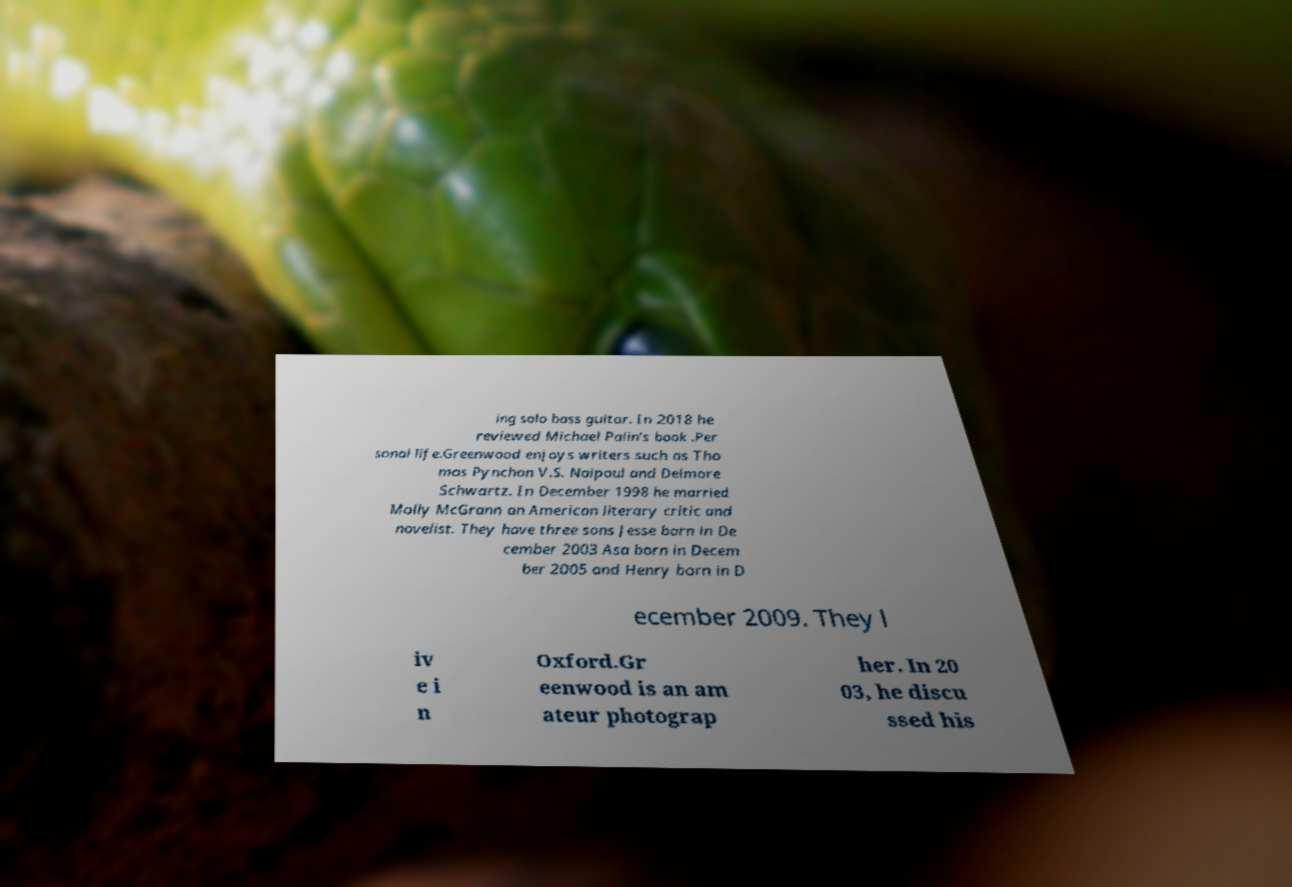Could you extract and type out the text from this image? ing solo bass guitar. In 2018 he reviewed Michael Palin's book .Per sonal life.Greenwood enjoys writers such as Tho mas Pynchon V.S. Naipaul and Delmore Schwartz. In December 1998 he married Molly McGrann an American literary critic and novelist. They have three sons Jesse born in De cember 2003 Asa born in Decem ber 2005 and Henry born in D ecember 2009. They l iv e i n Oxford.Gr eenwood is an am ateur photograp her. In 20 03, he discu ssed his 